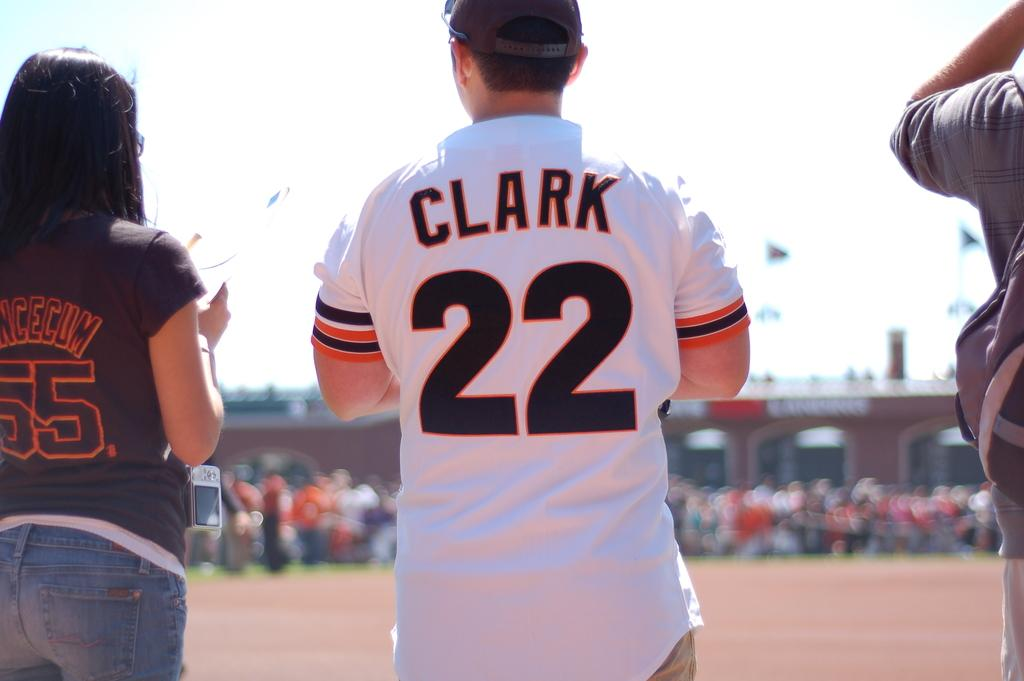<image>
Write a terse but informative summary of the picture. Clark is wearing a shirt with the number 22 on the back. 